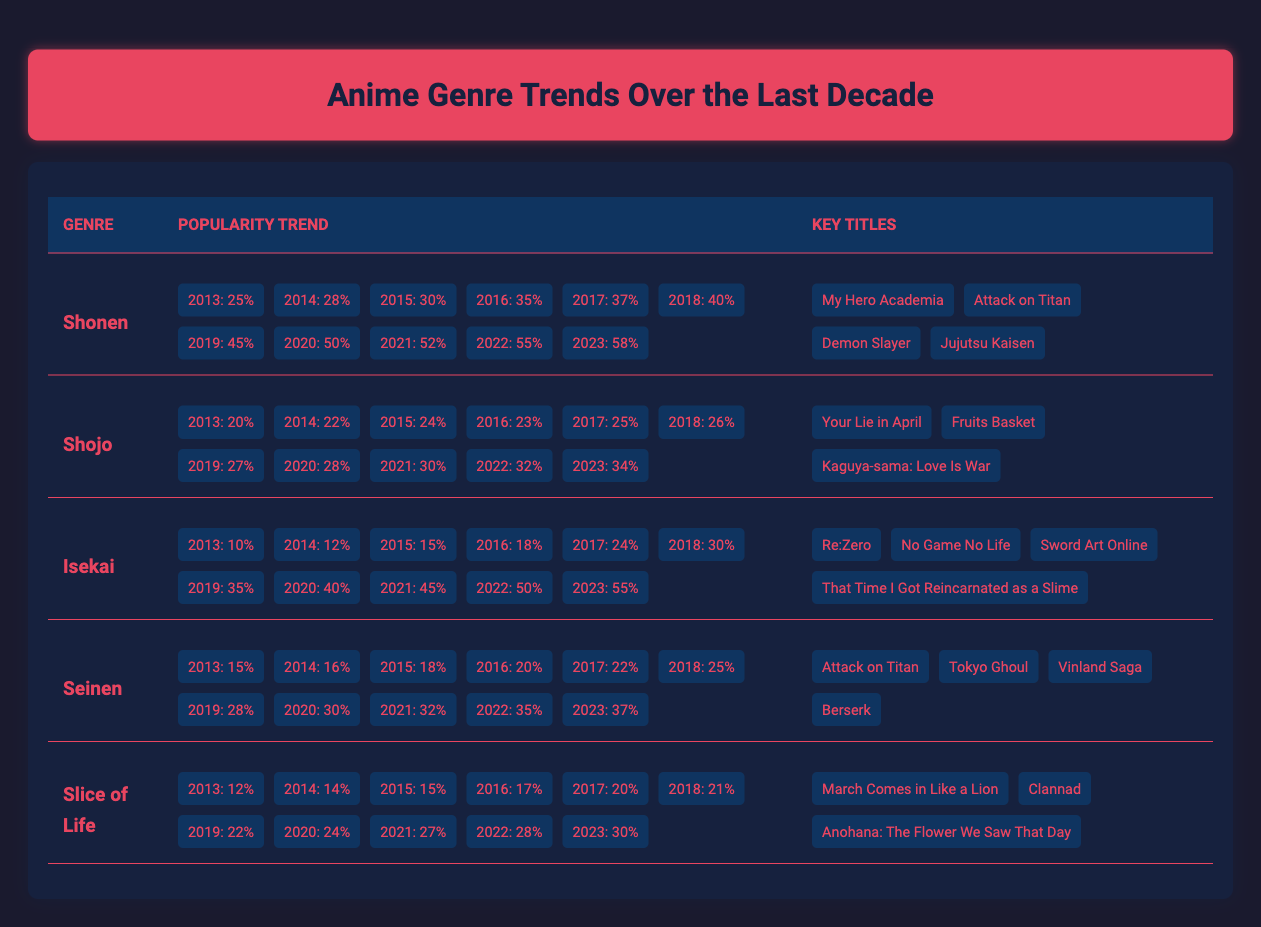What was the popularity percentage of the Shonen genre in 2020? The table shows the popularity trends for different anime genres. Looking specifically at the Shonen genre for the year 2020, the popularity percentage is displayed as 50% in that row.
Answer: 50% What is the average popularity of the Isekai genre over the last decade? The Isekai genre has the following popularity percentages over the years: 10, 12, 15, 18, 24, 30, 35, 40, 45, 50, and 55. To calculate the average, sum these values: 10 + 12 + 15 + 18 + 24 + 30 + 35 + 40 + 45 + 50 + 55 = 344. There are 11 years, so the average is 344 / 11 = 31.27, rounded to two decimal places is 31.27.
Answer: 31.27 Which genre had the highest popularity in 2023? Looking at the popularity percentages for each genre in 2023, Shonen has 58%, Isekai has 55%, Shojo has 34%, Seinen has 37%, and Slice of Life has 30%. Shonen has the highest percentage at 58%.
Answer: Shonen Did the popularity of Slice of Life ever exceed 25% over the last decade? Examining the popularity percentages for Slice of Life shows values: 12, 14, 15, 17, 20, 21, 22, 24, 27, 28, 30. The highest was 30%, but it never exceeded 25% until 2021 when it reached 27%. Therefore, the answer is yes, it eventually exceeded 25%.
Answer: Yes What is the difference in popularity between the Shonen and Seinen genres in 2022? The popularity of Shonen in 2022 is 55%, while for Seinen it is 35%. To find the difference, subtract Seinen's popularity from Shonen's: 55% - 35% = 20%.
Answer: 20% In which year did the Isekai genre first surpass 20% popularity? The Isekai genre's popularity was as follows: 10, 12, 15, 18, 24, etc. It first surpasses 20% in the year 2017 when it reaches 24%.
Answer: 2017 Which anime title is associated with the Shojo genre? From the Shojo genre row, the listed key titles include "Your Lie in April," "Fruits Basket," and "Kaguya-sama: Love Is War." Each title is directly associated with Shojo.
Answer: Your Lie in April, Fruits Basket, Kaguya-sama: Love Is War How did the popularity of the Seinen genre change from 2015 to 2023? The Seinen genre had the following popularity: 18% in 2015 and 37% in 2023. This indicates an increase of 19% over the years. To understand the change over time, we can see that it grew consistently each year.
Answer: Increased by 19% 